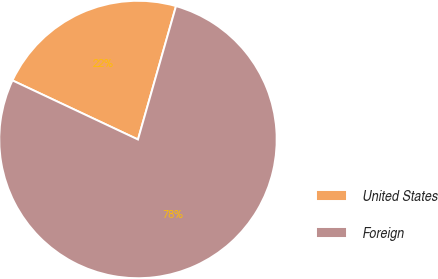<chart> <loc_0><loc_0><loc_500><loc_500><pie_chart><fcel>United States<fcel>Foreign<nl><fcel>22.42%<fcel>77.58%<nl></chart> 